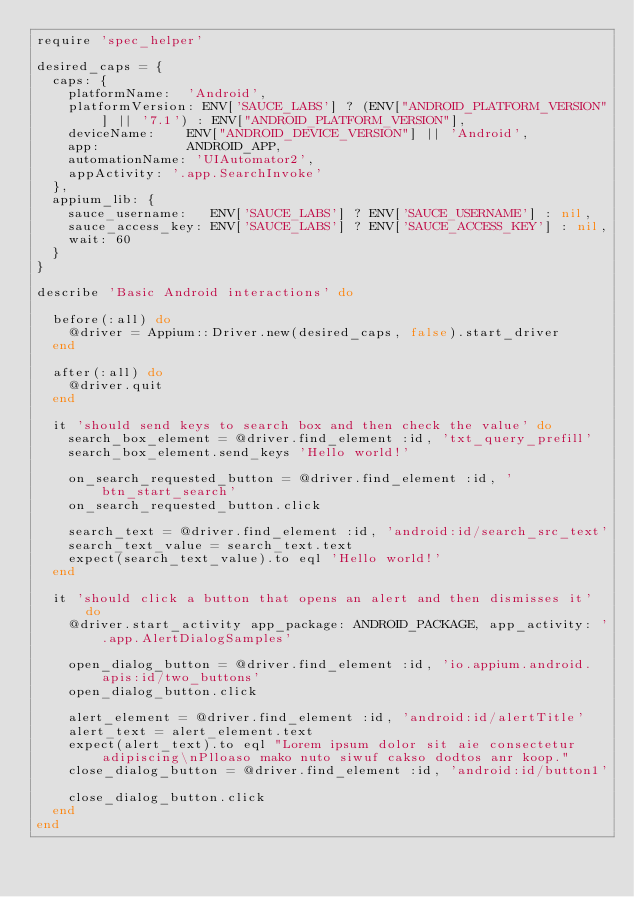Convert code to text. <code><loc_0><loc_0><loc_500><loc_500><_Ruby_>require 'spec_helper'

desired_caps = {
  caps: {
    platformName:  'Android',
    platformVersion: ENV['SAUCE_LABS'] ? (ENV["ANDROID_PLATFORM_VERSION"] || '7.1') : ENV["ANDROID_PLATFORM_VERSION"],
    deviceName:    ENV["ANDROID_DEVICE_VERSION"] || 'Android',
    app:           ANDROID_APP,
    automationName: 'UIAutomator2',
    appActivity: '.app.SearchInvoke'
  },
  appium_lib: {
    sauce_username:   ENV['SAUCE_LABS'] ? ENV['SAUCE_USERNAME'] : nil,
    sauce_access_key: ENV['SAUCE_LABS'] ? ENV['SAUCE_ACCESS_KEY'] : nil,
    wait: 60
  }
}

describe 'Basic Android interactions' do

  before(:all) do
    @driver = Appium::Driver.new(desired_caps, false).start_driver
  end

  after(:all) do
    @driver.quit
  end

  it 'should send keys to search box and then check the value' do
    search_box_element = @driver.find_element :id, 'txt_query_prefill'
    search_box_element.send_keys 'Hello world!'

    on_search_requested_button = @driver.find_element :id, 'btn_start_search'
    on_search_requested_button.click

    search_text = @driver.find_element :id, 'android:id/search_src_text'
    search_text_value = search_text.text
    expect(search_text_value).to eql 'Hello world!'
  end

  it 'should click a button that opens an alert and then dismisses it' do
    @driver.start_activity app_package: ANDROID_PACKAGE, app_activity: '.app.AlertDialogSamples'

    open_dialog_button = @driver.find_element :id, 'io.appium.android.apis:id/two_buttons'
    open_dialog_button.click

    alert_element = @driver.find_element :id, 'android:id/alertTitle'
    alert_text = alert_element.text
    expect(alert_text).to eql "Lorem ipsum dolor sit aie consectetur adipiscing\nPlloaso mako nuto siwuf cakso dodtos anr koop."
    close_dialog_button = @driver.find_element :id, 'android:id/button1'

    close_dialog_button.click
  end
end
</code> 